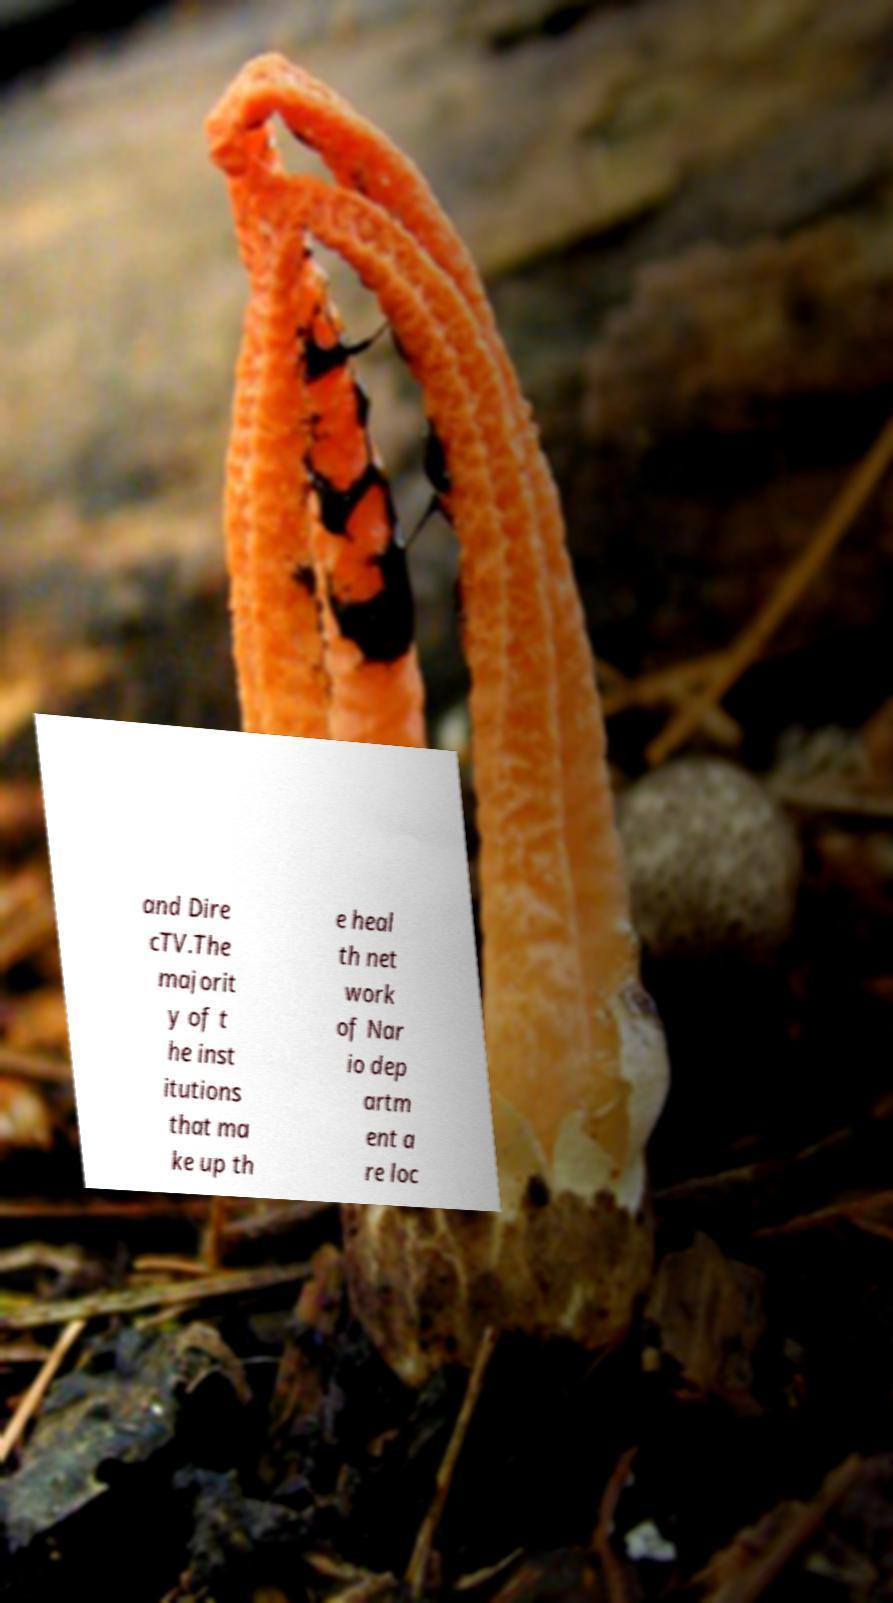Can you accurately transcribe the text from the provided image for me? and Dire cTV.The majorit y of t he inst itutions that ma ke up th e heal th net work of Nar io dep artm ent a re loc 